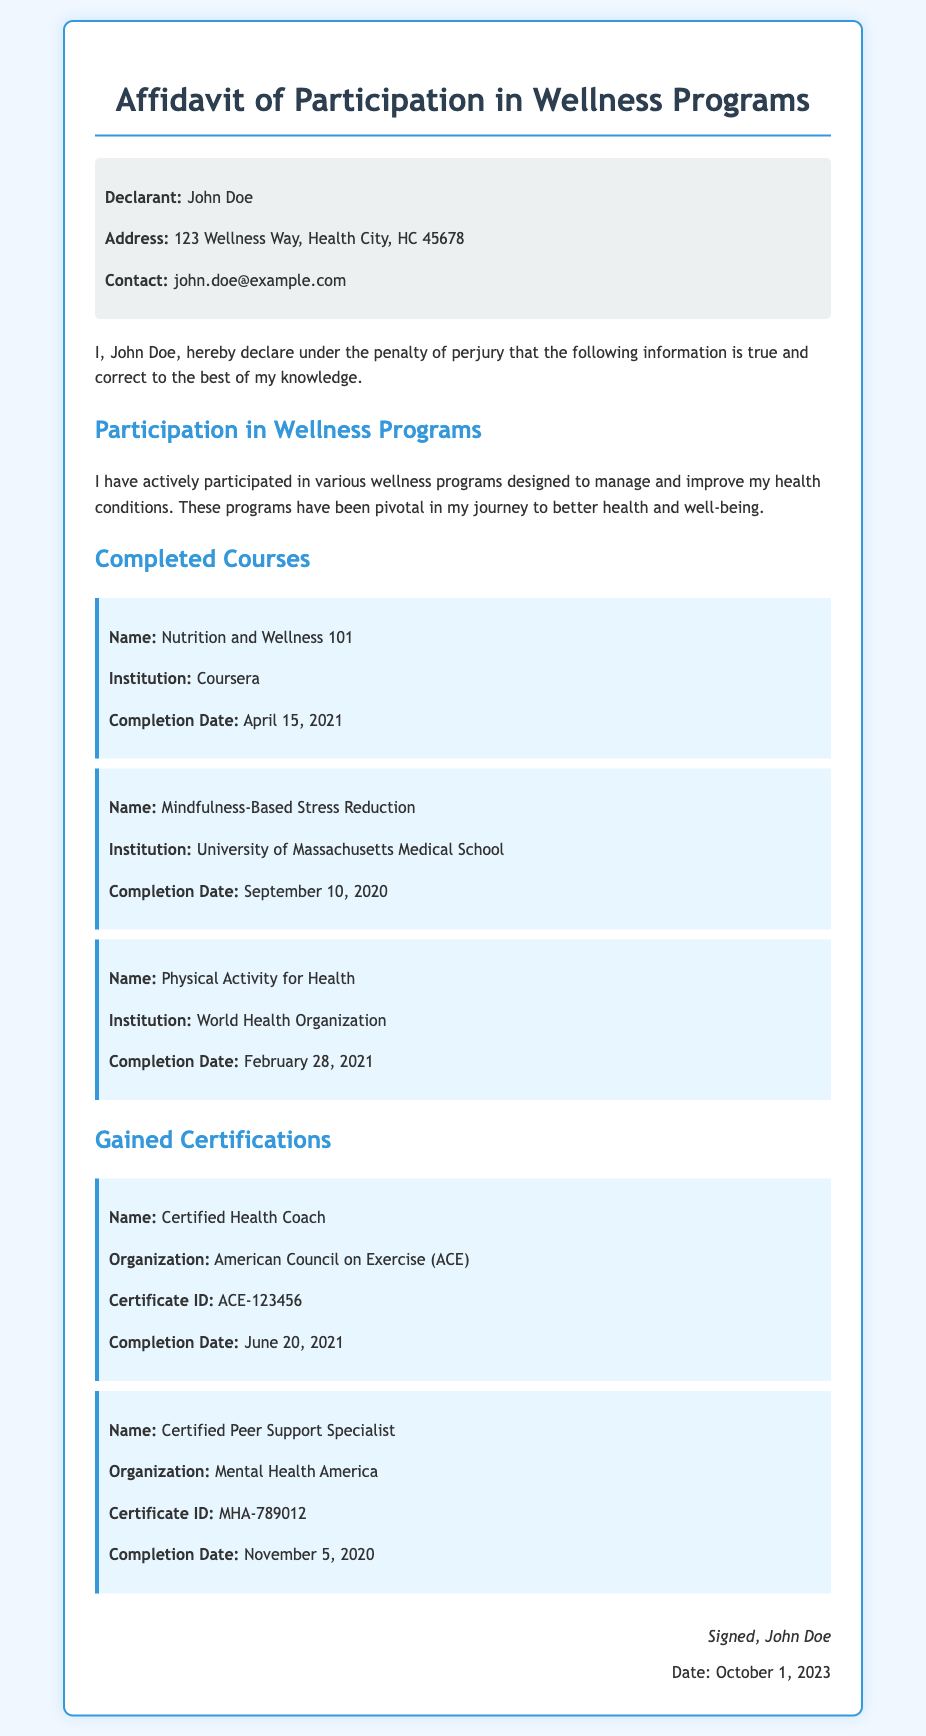What is the name of the declarant? The document states the declarant's name is John Doe.
Answer: John Doe What is the address of the declarant? The address provided in the document is 123 Wellness Way, Health City, HC 45678.
Answer: 123 Wellness Way, Health City, HC 45678 When was the course "Nutrition and Wellness 101" completed? The completion date listed for the course is April 15, 2021.
Answer: April 15, 2021 Which organization issued the "Certified Health Coach" certification? The organization that issued the certification is the American Council on Exercise (ACE).
Answer: American Council on Exercise (ACE) How many wellness programs does the declarant mention participating in? The document states that the declarant has actively participated in various wellness programs, but does not specify a number.
Answer: Various What are the completion dates of the certifications listed? The completion dates listed are June 20, 2021 for Certified Health Coach and November 5, 2020 for Certified Peer Support Specialist.
Answer: June 20, 2021 and November 5, 2020 What is the purpose of the affidavit? The affidavit serves to declare participation in wellness programs and completion of courses and certifications.
Answer: Participation in wellness programs What is the signature of the declarant? The signature of the declarant in the document is John Doe.
Answer: John Doe On what date was the affidavit signed? The date listed for the signing of the affidavit is October 1, 2023.
Answer: October 1, 2023 